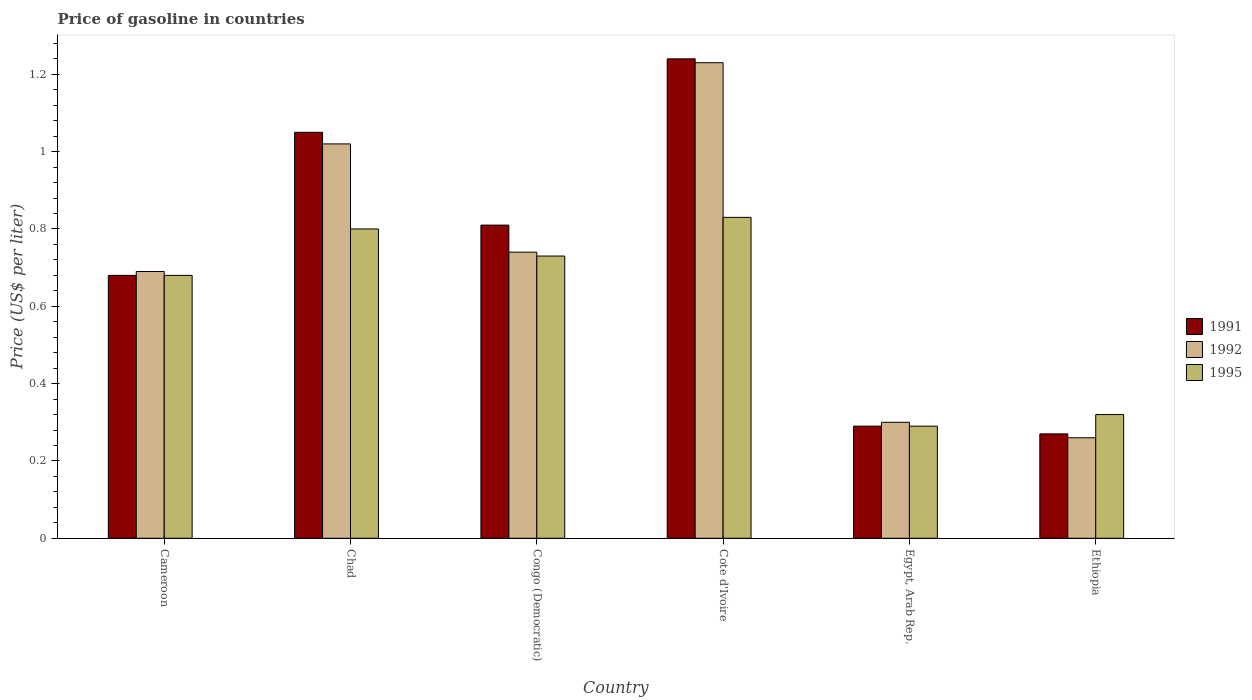How many different coloured bars are there?
Give a very brief answer. 3. How many groups of bars are there?
Give a very brief answer. 6. Are the number of bars per tick equal to the number of legend labels?
Your response must be concise. Yes. Are the number of bars on each tick of the X-axis equal?
Your answer should be compact. Yes. How many bars are there on the 6th tick from the left?
Provide a short and direct response. 3. What is the label of the 6th group of bars from the left?
Keep it short and to the point. Ethiopia. In how many cases, is the number of bars for a given country not equal to the number of legend labels?
Keep it short and to the point. 0. What is the price of gasoline in 1992 in Cameroon?
Your response must be concise. 0.69. Across all countries, what is the maximum price of gasoline in 1992?
Make the answer very short. 1.23. Across all countries, what is the minimum price of gasoline in 1995?
Provide a short and direct response. 0.29. In which country was the price of gasoline in 1995 maximum?
Provide a succinct answer. Cote d'Ivoire. In which country was the price of gasoline in 1995 minimum?
Make the answer very short. Egypt, Arab Rep. What is the total price of gasoline in 1991 in the graph?
Make the answer very short. 4.34. What is the difference between the price of gasoline in 1992 in Congo (Democratic) and that in Ethiopia?
Your response must be concise. 0.48. What is the difference between the price of gasoline in 1995 in Ethiopia and the price of gasoline in 1991 in Egypt, Arab Rep.?
Keep it short and to the point. 0.03. What is the average price of gasoline in 1991 per country?
Your answer should be compact. 0.72. What is the difference between the price of gasoline of/in 1995 and price of gasoline of/in 1991 in Ethiopia?
Your answer should be very brief. 0.05. In how many countries, is the price of gasoline in 1992 greater than 0.88 US$?
Provide a short and direct response. 2. What is the difference between the highest and the second highest price of gasoline in 1992?
Your answer should be compact. -0.49. What is the difference between the highest and the lowest price of gasoline in 1991?
Offer a terse response. 0.97. In how many countries, is the price of gasoline in 1991 greater than the average price of gasoline in 1991 taken over all countries?
Offer a terse response. 3. Is it the case that in every country, the sum of the price of gasoline in 1991 and price of gasoline in 1995 is greater than the price of gasoline in 1992?
Offer a very short reply. Yes. How many bars are there?
Offer a very short reply. 18. Are all the bars in the graph horizontal?
Provide a succinct answer. No. How many countries are there in the graph?
Keep it short and to the point. 6. How are the legend labels stacked?
Keep it short and to the point. Vertical. What is the title of the graph?
Provide a succinct answer. Price of gasoline in countries. What is the label or title of the Y-axis?
Your response must be concise. Price (US$ per liter). What is the Price (US$ per liter) of 1991 in Cameroon?
Give a very brief answer. 0.68. What is the Price (US$ per liter) of 1992 in Cameroon?
Your answer should be compact. 0.69. What is the Price (US$ per liter) in 1995 in Cameroon?
Your answer should be compact. 0.68. What is the Price (US$ per liter) of 1991 in Congo (Democratic)?
Your response must be concise. 0.81. What is the Price (US$ per liter) of 1992 in Congo (Democratic)?
Your answer should be very brief. 0.74. What is the Price (US$ per liter) of 1995 in Congo (Democratic)?
Provide a short and direct response. 0.73. What is the Price (US$ per liter) in 1991 in Cote d'Ivoire?
Ensure brevity in your answer.  1.24. What is the Price (US$ per liter) in 1992 in Cote d'Ivoire?
Make the answer very short. 1.23. What is the Price (US$ per liter) in 1995 in Cote d'Ivoire?
Your answer should be very brief. 0.83. What is the Price (US$ per liter) in 1991 in Egypt, Arab Rep.?
Provide a succinct answer. 0.29. What is the Price (US$ per liter) in 1995 in Egypt, Arab Rep.?
Your response must be concise. 0.29. What is the Price (US$ per liter) of 1991 in Ethiopia?
Provide a short and direct response. 0.27. What is the Price (US$ per liter) in 1992 in Ethiopia?
Provide a succinct answer. 0.26. What is the Price (US$ per liter) in 1995 in Ethiopia?
Your answer should be compact. 0.32. Across all countries, what is the maximum Price (US$ per liter) in 1991?
Your response must be concise. 1.24. Across all countries, what is the maximum Price (US$ per liter) of 1992?
Ensure brevity in your answer.  1.23. Across all countries, what is the maximum Price (US$ per liter) of 1995?
Give a very brief answer. 0.83. Across all countries, what is the minimum Price (US$ per liter) in 1991?
Offer a terse response. 0.27. Across all countries, what is the minimum Price (US$ per liter) of 1992?
Provide a succinct answer. 0.26. Across all countries, what is the minimum Price (US$ per liter) in 1995?
Provide a short and direct response. 0.29. What is the total Price (US$ per liter) of 1991 in the graph?
Give a very brief answer. 4.34. What is the total Price (US$ per liter) in 1992 in the graph?
Provide a succinct answer. 4.24. What is the total Price (US$ per liter) in 1995 in the graph?
Offer a terse response. 3.65. What is the difference between the Price (US$ per liter) of 1991 in Cameroon and that in Chad?
Keep it short and to the point. -0.37. What is the difference between the Price (US$ per liter) of 1992 in Cameroon and that in Chad?
Provide a succinct answer. -0.33. What is the difference between the Price (US$ per liter) in 1995 in Cameroon and that in Chad?
Your answer should be compact. -0.12. What is the difference between the Price (US$ per liter) in 1991 in Cameroon and that in Congo (Democratic)?
Your answer should be very brief. -0.13. What is the difference between the Price (US$ per liter) in 1995 in Cameroon and that in Congo (Democratic)?
Your response must be concise. -0.05. What is the difference between the Price (US$ per liter) of 1991 in Cameroon and that in Cote d'Ivoire?
Keep it short and to the point. -0.56. What is the difference between the Price (US$ per liter) of 1992 in Cameroon and that in Cote d'Ivoire?
Your answer should be compact. -0.54. What is the difference between the Price (US$ per liter) of 1991 in Cameroon and that in Egypt, Arab Rep.?
Your answer should be very brief. 0.39. What is the difference between the Price (US$ per liter) of 1992 in Cameroon and that in Egypt, Arab Rep.?
Give a very brief answer. 0.39. What is the difference between the Price (US$ per liter) in 1995 in Cameroon and that in Egypt, Arab Rep.?
Give a very brief answer. 0.39. What is the difference between the Price (US$ per liter) of 1991 in Cameroon and that in Ethiopia?
Offer a very short reply. 0.41. What is the difference between the Price (US$ per liter) of 1992 in Cameroon and that in Ethiopia?
Keep it short and to the point. 0.43. What is the difference between the Price (US$ per liter) of 1995 in Cameroon and that in Ethiopia?
Your answer should be very brief. 0.36. What is the difference between the Price (US$ per liter) in 1991 in Chad and that in Congo (Democratic)?
Provide a succinct answer. 0.24. What is the difference between the Price (US$ per liter) in 1992 in Chad and that in Congo (Democratic)?
Your answer should be compact. 0.28. What is the difference between the Price (US$ per liter) in 1995 in Chad and that in Congo (Democratic)?
Provide a succinct answer. 0.07. What is the difference between the Price (US$ per liter) in 1991 in Chad and that in Cote d'Ivoire?
Offer a terse response. -0.19. What is the difference between the Price (US$ per liter) in 1992 in Chad and that in Cote d'Ivoire?
Give a very brief answer. -0.21. What is the difference between the Price (US$ per liter) of 1995 in Chad and that in Cote d'Ivoire?
Offer a terse response. -0.03. What is the difference between the Price (US$ per liter) of 1991 in Chad and that in Egypt, Arab Rep.?
Give a very brief answer. 0.76. What is the difference between the Price (US$ per liter) of 1992 in Chad and that in Egypt, Arab Rep.?
Ensure brevity in your answer.  0.72. What is the difference between the Price (US$ per liter) of 1995 in Chad and that in Egypt, Arab Rep.?
Your response must be concise. 0.51. What is the difference between the Price (US$ per liter) of 1991 in Chad and that in Ethiopia?
Give a very brief answer. 0.78. What is the difference between the Price (US$ per liter) of 1992 in Chad and that in Ethiopia?
Provide a short and direct response. 0.76. What is the difference between the Price (US$ per liter) of 1995 in Chad and that in Ethiopia?
Offer a very short reply. 0.48. What is the difference between the Price (US$ per liter) of 1991 in Congo (Democratic) and that in Cote d'Ivoire?
Offer a terse response. -0.43. What is the difference between the Price (US$ per liter) in 1992 in Congo (Democratic) and that in Cote d'Ivoire?
Give a very brief answer. -0.49. What is the difference between the Price (US$ per liter) in 1995 in Congo (Democratic) and that in Cote d'Ivoire?
Provide a short and direct response. -0.1. What is the difference between the Price (US$ per liter) in 1991 in Congo (Democratic) and that in Egypt, Arab Rep.?
Keep it short and to the point. 0.52. What is the difference between the Price (US$ per liter) of 1992 in Congo (Democratic) and that in Egypt, Arab Rep.?
Your answer should be very brief. 0.44. What is the difference between the Price (US$ per liter) of 1995 in Congo (Democratic) and that in Egypt, Arab Rep.?
Provide a short and direct response. 0.44. What is the difference between the Price (US$ per liter) in 1991 in Congo (Democratic) and that in Ethiopia?
Ensure brevity in your answer.  0.54. What is the difference between the Price (US$ per liter) of 1992 in Congo (Democratic) and that in Ethiopia?
Ensure brevity in your answer.  0.48. What is the difference between the Price (US$ per liter) of 1995 in Congo (Democratic) and that in Ethiopia?
Give a very brief answer. 0.41. What is the difference between the Price (US$ per liter) in 1991 in Cote d'Ivoire and that in Egypt, Arab Rep.?
Your answer should be very brief. 0.95. What is the difference between the Price (US$ per liter) in 1992 in Cote d'Ivoire and that in Egypt, Arab Rep.?
Make the answer very short. 0.93. What is the difference between the Price (US$ per liter) of 1995 in Cote d'Ivoire and that in Egypt, Arab Rep.?
Offer a very short reply. 0.54. What is the difference between the Price (US$ per liter) in 1991 in Cote d'Ivoire and that in Ethiopia?
Your answer should be very brief. 0.97. What is the difference between the Price (US$ per liter) in 1995 in Cote d'Ivoire and that in Ethiopia?
Your response must be concise. 0.51. What is the difference between the Price (US$ per liter) in 1991 in Egypt, Arab Rep. and that in Ethiopia?
Your answer should be compact. 0.02. What is the difference between the Price (US$ per liter) in 1995 in Egypt, Arab Rep. and that in Ethiopia?
Keep it short and to the point. -0.03. What is the difference between the Price (US$ per liter) in 1991 in Cameroon and the Price (US$ per liter) in 1992 in Chad?
Your response must be concise. -0.34. What is the difference between the Price (US$ per liter) of 1991 in Cameroon and the Price (US$ per liter) of 1995 in Chad?
Make the answer very short. -0.12. What is the difference between the Price (US$ per liter) of 1992 in Cameroon and the Price (US$ per liter) of 1995 in Chad?
Your response must be concise. -0.11. What is the difference between the Price (US$ per liter) of 1991 in Cameroon and the Price (US$ per liter) of 1992 in Congo (Democratic)?
Provide a succinct answer. -0.06. What is the difference between the Price (US$ per liter) of 1991 in Cameroon and the Price (US$ per liter) of 1995 in Congo (Democratic)?
Offer a terse response. -0.05. What is the difference between the Price (US$ per liter) of 1992 in Cameroon and the Price (US$ per liter) of 1995 in Congo (Democratic)?
Your answer should be very brief. -0.04. What is the difference between the Price (US$ per liter) of 1991 in Cameroon and the Price (US$ per liter) of 1992 in Cote d'Ivoire?
Make the answer very short. -0.55. What is the difference between the Price (US$ per liter) of 1991 in Cameroon and the Price (US$ per liter) of 1995 in Cote d'Ivoire?
Provide a succinct answer. -0.15. What is the difference between the Price (US$ per liter) in 1992 in Cameroon and the Price (US$ per liter) in 1995 in Cote d'Ivoire?
Provide a succinct answer. -0.14. What is the difference between the Price (US$ per liter) in 1991 in Cameroon and the Price (US$ per liter) in 1992 in Egypt, Arab Rep.?
Your response must be concise. 0.38. What is the difference between the Price (US$ per liter) of 1991 in Cameroon and the Price (US$ per liter) of 1995 in Egypt, Arab Rep.?
Offer a terse response. 0.39. What is the difference between the Price (US$ per liter) in 1991 in Cameroon and the Price (US$ per liter) in 1992 in Ethiopia?
Ensure brevity in your answer.  0.42. What is the difference between the Price (US$ per liter) of 1991 in Cameroon and the Price (US$ per liter) of 1995 in Ethiopia?
Make the answer very short. 0.36. What is the difference between the Price (US$ per liter) in 1992 in Cameroon and the Price (US$ per liter) in 1995 in Ethiopia?
Provide a succinct answer. 0.37. What is the difference between the Price (US$ per liter) in 1991 in Chad and the Price (US$ per liter) in 1992 in Congo (Democratic)?
Provide a succinct answer. 0.31. What is the difference between the Price (US$ per liter) in 1991 in Chad and the Price (US$ per liter) in 1995 in Congo (Democratic)?
Ensure brevity in your answer.  0.32. What is the difference between the Price (US$ per liter) in 1992 in Chad and the Price (US$ per liter) in 1995 in Congo (Democratic)?
Give a very brief answer. 0.29. What is the difference between the Price (US$ per liter) in 1991 in Chad and the Price (US$ per liter) in 1992 in Cote d'Ivoire?
Your answer should be very brief. -0.18. What is the difference between the Price (US$ per liter) in 1991 in Chad and the Price (US$ per liter) in 1995 in Cote d'Ivoire?
Offer a very short reply. 0.22. What is the difference between the Price (US$ per liter) in 1992 in Chad and the Price (US$ per liter) in 1995 in Cote d'Ivoire?
Your response must be concise. 0.19. What is the difference between the Price (US$ per liter) in 1991 in Chad and the Price (US$ per liter) in 1992 in Egypt, Arab Rep.?
Provide a short and direct response. 0.75. What is the difference between the Price (US$ per liter) in 1991 in Chad and the Price (US$ per liter) in 1995 in Egypt, Arab Rep.?
Provide a short and direct response. 0.76. What is the difference between the Price (US$ per liter) in 1992 in Chad and the Price (US$ per liter) in 1995 in Egypt, Arab Rep.?
Keep it short and to the point. 0.73. What is the difference between the Price (US$ per liter) of 1991 in Chad and the Price (US$ per liter) of 1992 in Ethiopia?
Provide a short and direct response. 0.79. What is the difference between the Price (US$ per liter) in 1991 in Chad and the Price (US$ per liter) in 1995 in Ethiopia?
Your answer should be very brief. 0.73. What is the difference between the Price (US$ per liter) in 1991 in Congo (Democratic) and the Price (US$ per liter) in 1992 in Cote d'Ivoire?
Provide a short and direct response. -0.42. What is the difference between the Price (US$ per liter) in 1991 in Congo (Democratic) and the Price (US$ per liter) in 1995 in Cote d'Ivoire?
Offer a very short reply. -0.02. What is the difference between the Price (US$ per liter) of 1992 in Congo (Democratic) and the Price (US$ per liter) of 1995 in Cote d'Ivoire?
Provide a succinct answer. -0.09. What is the difference between the Price (US$ per liter) of 1991 in Congo (Democratic) and the Price (US$ per liter) of 1992 in Egypt, Arab Rep.?
Your answer should be compact. 0.51. What is the difference between the Price (US$ per liter) of 1991 in Congo (Democratic) and the Price (US$ per liter) of 1995 in Egypt, Arab Rep.?
Your answer should be compact. 0.52. What is the difference between the Price (US$ per liter) of 1992 in Congo (Democratic) and the Price (US$ per liter) of 1995 in Egypt, Arab Rep.?
Offer a terse response. 0.45. What is the difference between the Price (US$ per liter) in 1991 in Congo (Democratic) and the Price (US$ per liter) in 1992 in Ethiopia?
Offer a very short reply. 0.55. What is the difference between the Price (US$ per liter) of 1991 in Congo (Democratic) and the Price (US$ per liter) of 1995 in Ethiopia?
Keep it short and to the point. 0.49. What is the difference between the Price (US$ per liter) of 1992 in Congo (Democratic) and the Price (US$ per liter) of 1995 in Ethiopia?
Offer a terse response. 0.42. What is the difference between the Price (US$ per liter) of 1991 in Cote d'Ivoire and the Price (US$ per liter) of 1995 in Egypt, Arab Rep.?
Give a very brief answer. 0.95. What is the difference between the Price (US$ per liter) of 1992 in Cote d'Ivoire and the Price (US$ per liter) of 1995 in Egypt, Arab Rep.?
Your response must be concise. 0.94. What is the difference between the Price (US$ per liter) of 1991 in Cote d'Ivoire and the Price (US$ per liter) of 1995 in Ethiopia?
Your answer should be compact. 0.92. What is the difference between the Price (US$ per liter) in 1992 in Cote d'Ivoire and the Price (US$ per liter) in 1995 in Ethiopia?
Your answer should be very brief. 0.91. What is the difference between the Price (US$ per liter) of 1991 in Egypt, Arab Rep. and the Price (US$ per liter) of 1995 in Ethiopia?
Ensure brevity in your answer.  -0.03. What is the difference between the Price (US$ per liter) of 1992 in Egypt, Arab Rep. and the Price (US$ per liter) of 1995 in Ethiopia?
Your answer should be very brief. -0.02. What is the average Price (US$ per liter) of 1991 per country?
Give a very brief answer. 0.72. What is the average Price (US$ per liter) in 1992 per country?
Ensure brevity in your answer.  0.71. What is the average Price (US$ per liter) in 1995 per country?
Offer a very short reply. 0.61. What is the difference between the Price (US$ per liter) in 1991 and Price (US$ per liter) in 1992 in Cameroon?
Your response must be concise. -0.01. What is the difference between the Price (US$ per liter) of 1991 and Price (US$ per liter) of 1995 in Cameroon?
Provide a short and direct response. 0. What is the difference between the Price (US$ per liter) of 1992 and Price (US$ per liter) of 1995 in Cameroon?
Give a very brief answer. 0.01. What is the difference between the Price (US$ per liter) in 1991 and Price (US$ per liter) in 1992 in Chad?
Your answer should be very brief. 0.03. What is the difference between the Price (US$ per liter) in 1992 and Price (US$ per liter) in 1995 in Chad?
Offer a terse response. 0.22. What is the difference between the Price (US$ per liter) of 1991 and Price (US$ per liter) of 1992 in Congo (Democratic)?
Keep it short and to the point. 0.07. What is the difference between the Price (US$ per liter) of 1991 and Price (US$ per liter) of 1992 in Cote d'Ivoire?
Provide a short and direct response. 0.01. What is the difference between the Price (US$ per liter) of 1991 and Price (US$ per liter) of 1995 in Cote d'Ivoire?
Offer a terse response. 0.41. What is the difference between the Price (US$ per liter) in 1992 and Price (US$ per liter) in 1995 in Cote d'Ivoire?
Your answer should be very brief. 0.4. What is the difference between the Price (US$ per liter) in 1991 and Price (US$ per liter) in 1992 in Egypt, Arab Rep.?
Your answer should be very brief. -0.01. What is the difference between the Price (US$ per liter) of 1991 and Price (US$ per liter) of 1992 in Ethiopia?
Your answer should be very brief. 0.01. What is the difference between the Price (US$ per liter) of 1992 and Price (US$ per liter) of 1995 in Ethiopia?
Offer a very short reply. -0.06. What is the ratio of the Price (US$ per liter) in 1991 in Cameroon to that in Chad?
Offer a very short reply. 0.65. What is the ratio of the Price (US$ per liter) of 1992 in Cameroon to that in Chad?
Give a very brief answer. 0.68. What is the ratio of the Price (US$ per liter) in 1991 in Cameroon to that in Congo (Democratic)?
Ensure brevity in your answer.  0.84. What is the ratio of the Price (US$ per liter) in 1992 in Cameroon to that in Congo (Democratic)?
Your answer should be compact. 0.93. What is the ratio of the Price (US$ per liter) of 1995 in Cameroon to that in Congo (Democratic)?
Make the answer very short. 0.93. What is the ratio of the Price (US$ per liter) of 1991 in Cameroon to that in Cote d'Ivoire?
Your answer should be compact. 0.55. What is the ratio of the Price (US$ per liter) of 1992 in Cameroon to that in Cote d'Ivoire?
Give a very brief answer. 0.56. What is the ratio of the Price (US$ per liter) of 1995 in Cameroon to that in Cote d'Ivoire?
Make the answer very short. 0.82. What is the ratio of the Price (US$ per liter) of 1991 in Cameroon to that in Egypt, Arab Rep.?
Your response must be concise. 2.34. What is the ratio of the Price (US$ per liter) of 1992 in Cameroon to that in Egypt, Arab Rep.?
Your answer should be very brief. 2.3. What is the ratio of the Price (US$ per liter) in 1995 in Cameroon to that in Egypt, Arab Rep.?
Give a very brief answer. 2.34. What is the ratio of the Price (US$ per liter) in 1991 in Cameroon to that in Ethiopia?
Keep it short and to the point. 2.52. What is the ratio of the Price (US$ per liter) in 1992 in Cameroon to that in Ethiopia?
Keep it short and to the point. 2.65. What is the ratio of the Price (US$ per liter) in 1995 in Cameroon to that in Ethiopia?
Keep it short and to the point. 2.12. What is the ratio of the Price (US$ per liter) of 1991 in Chad to that in Congo (Democratic)?
Your answer should be very brief. 1.3. What is the ratio of the Price (US$ per liter) of 1992 in Chad to that in Congo (Democratic)?
Offer a very short reply. 1.38. What is the ratio of the Price (US$ per liter) of 1995 in Chad to that in Congo (Democratic)?
Offer a very short reply. 1.1. What is the ratio of the Price (US$ per liter) of 1991 in Chad to that in Cote d'Ivoire?
Keep it short and to the point. 0.85. What is the ratio of the Price (US$ per liter) of 1992 in Chad to that in Cote d'Ivoire?
Your answer should be very brief. 0.83. What is the ratio of the Price (US$ per liter) of 1995 in Chad to that in Cote d'Ivoire?
Give a very brief answer. 0.96. What is the ratio of the Price (US$ per liter) of 1991 in Chad to that in Egypt, Arab Rep.?
Provide a succinct answer. 3.62. What is the ratio of the Price (US$ per liter) in 1995 in Chad to that in Egypt, Arab Rep.?
Your answer should be very brief. 2.76. What is the ratio of the Price (US$ per liter) in 1991 in Chad to that in Ethiopia?
Provide a short and direct response. 3.89. What is the ratio of the Price (US$ per liter) of 1992 in Chad to that in Ethiopia?
Give a very brief answer. 3.92. What is the ratio of the Price (US$ per liter) in 1991 in Congo (Democratic) to that in Cote d'Ivoire?
Give a very brief answer. 0.65. What is the ratio of the Price (US$ per liter) of 1992 in Congo (Democratic) to that in Cote d'Ivoire?
Ensure brevity in your answer.  0.6. What is the ratio of the Price (US$ per liter) in 1995 in Congo (Democratic) to that in Cote d'Ivoire?
Your answer should be very brief. 0.88. What is the ratio of the Price (US$ per liter) in 1991 in Congo (Democratic) to that in Egypt, Arab Rep.?
Make the answer very short. 2.79. What is the ratio of the Price (US$ per liter) of 1992 in Congo (Democratic) to that in Egypt, Arab Rep.?
Provide a short and direct response. 2.47. What is the ratio of the Price (US$ per liter) of 1995 in Congo (Democratic) to that in Egypt, Arab Rep.?
Your answer should be compact. 2.52. What is the ratio of the Price (US$ per liter) in 1991 in Congo (Democratic) to that in Ethiopia?
Give a very brief answer. 3. What is the ratio of the Price (US$ per liter) of 1992 in Congo (Democratic) to that in Ethiopia?
Provide a succinct answer. 2.85. What is the ratio of the Price (US$ per liter) in 1995 in Congo (Democratic) to that in Ethiopia?
Make the answer very short. 2.28. What is the ratio of the Price (US$ per liter) in 1991 in Cote d'Ivoire to that in Egypt, Arab Rep.?
Keep it short and to the point. 4.28. What is the ratio of the Price (US$ per liter) in 1992 in Cote d'Ivoire to that in Egypt, Arab Rep.?
Offer a terse response. 4.1. What is the ratio of the Price (US$ per liter) in 1995 in Cote d'Ivoire to that in Egypt, Arab Rep.?
Offer a very short reply. 2.86. What is the ratio of the Price (US$ per liter) in 1991 in Cote d'Ivoire to that in Ethiopia?
Your answer should be very brief. 4.59. What is the ratio of the Price (US$ per liter) in 1992 in Cote d'Ivoire to that in Ethiopia?
Give a very brief answer. 4.73. What is the ratio of the Price (US$ per liter) in 1995 in Cote d'Ivoire to that in Ethiopia?
Keep it short and to the point. 2.59. What is the ratio of the Price (US$ per liter) in 1991 in Egypt, Arab Rep. to that in Ethiopia?
Ensure brevity in your answer.  1.07. What is the ratio of the Price (US$ per liter) of 1992 in Egypt, Arab Rep. to that in Ethiopia?
Keep it short and to the point. 1.15. What is the ratio of the Price (US$ per liter) of 1995 in Egypt, Arab Rep. to that in Ethiopia?
Offer a very short reply. 0.91. What is the difference between the highest and the second highest Price (US$ per liter) in 1991?
Ensure brevity in your answer.  0.19. What is the difference between the highest and the second highest Price (US$ per liter) in 1992?
Keep it short and to the point. 0.21. What is the difference between the highest and the second highest Price (US$ per liter) in 1995?
Your response must be concise. 0.03. What is the difference between the highest and the lowest Price (US$ per liter) of 1991?
Offer a terse response. 0.97. What is the difference between the highest and the lowest Price (US$ per liter) of 1995?
Offer a terse response. 0.54. 